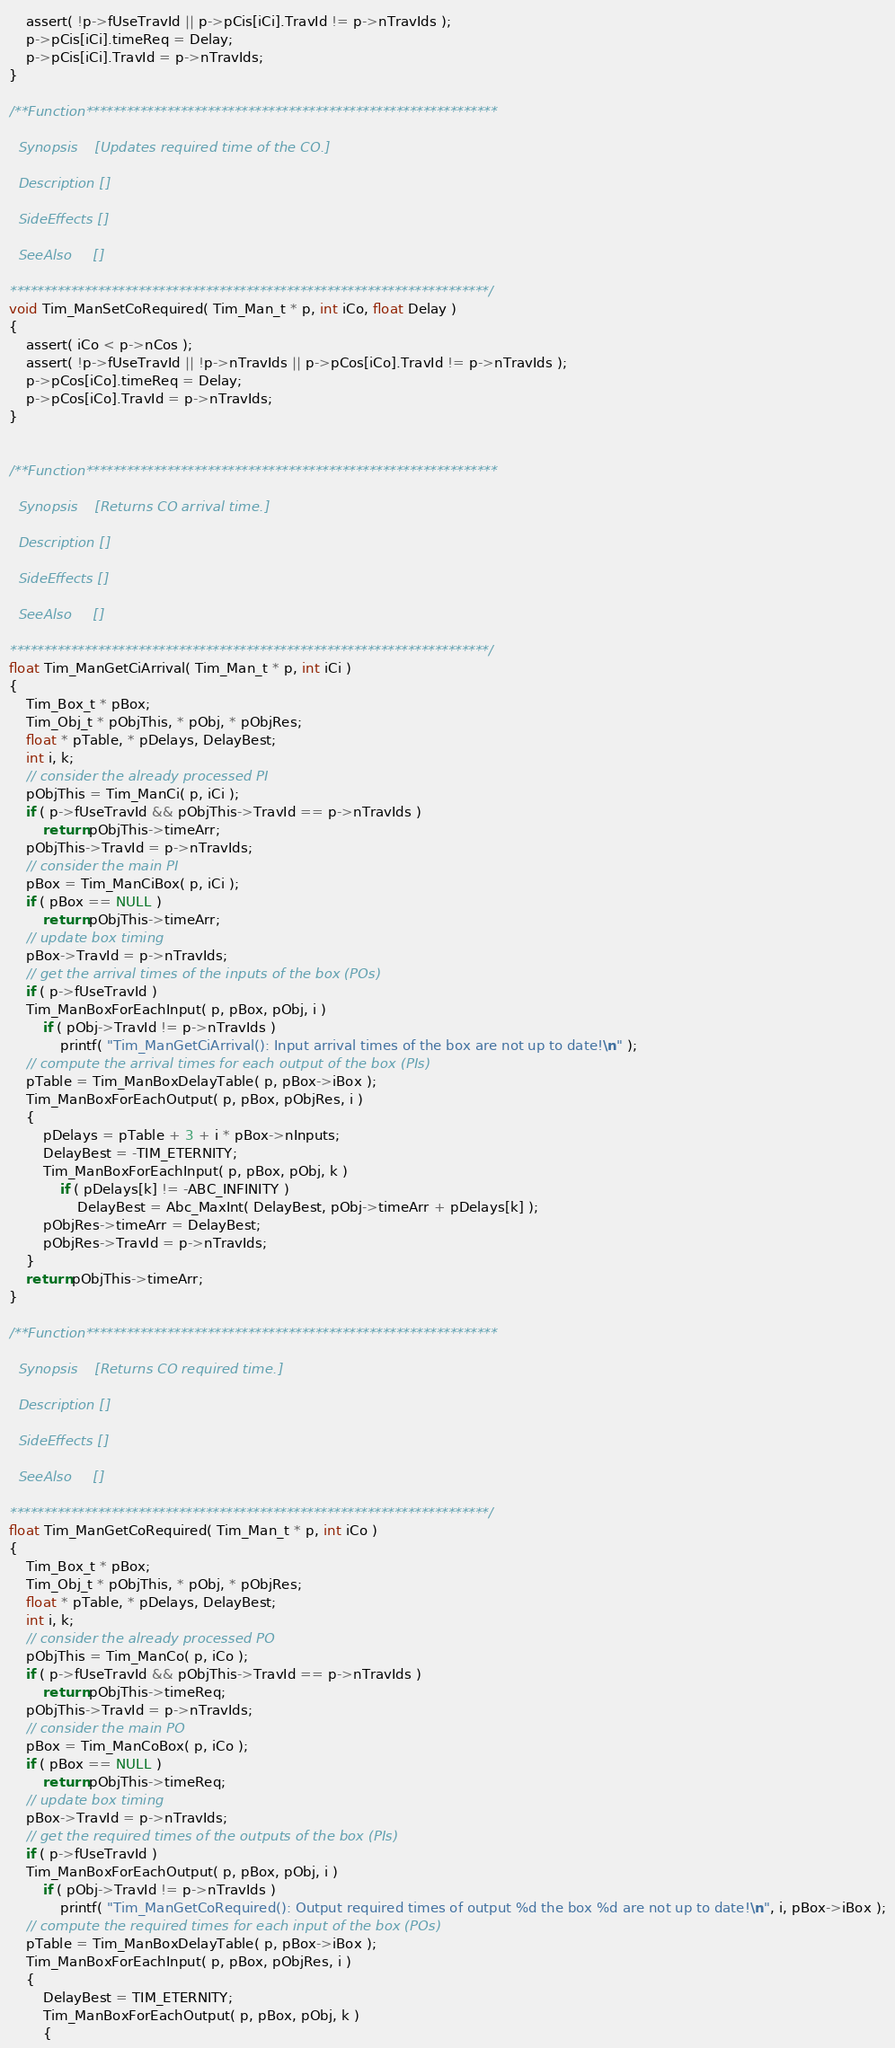Convert code to text. <code><loc_0><loc_0><loc_500><loc_500><_C_>    assert( !p->fUseTravId || p->pCis[iCi].TravId != p->nTravIds );
    p->pCis[iCi].timeReq = Delay;
    p->pCis[iCi].TravId = p->nTravIds;
}

/**Function*************************************************************

  Synopsis    [Updates required time of the CO.]

  Description []
               
  SideEffects []

  SeeAlso     []

***********************************************************************/
void Tim_ManSetCoRequired( Tim_Man_t * p, int iCo, float Delay )
{
    assert( iCo < p->nCos );
    assert( !p->fUseTravId || !p->nTravIds || p->pCos[iCo].TravId != p->nTravIds );
    p->pCos[iCo].timeReq = Delay;
    p->pCos[iCo].TravId = p->nTravIds;
}


/**Function*************************************************************

  Synopsis    [Returns CO arrival time.]

  Description []
               
  SideEffects []

  SeeAlso     []

***********************************************************************/
float Tim_ManGetCiArrival( Tim_Man_t * p, int iCi )
{
    Tim_Box_t * pBox;
    Tim_Obj_t * pObjThis, * pObj, * pObjRes;
    float * pTable, * pDelays, DelayBest;
    int i, k;
    // consider the already processed PI
    pObjThis = Tim_ManCi( p, iCi );
    if ( p->fUseTravId && pObjThis->TravId == p->nTravIds )
        return pObjThis->timeArr;
    pObjThis->TravId = p->nTravIds;
    // consider the main PI
    pBox = Tim_ManCiBox( p, iCi );
    if ( pBox == NULL )
        return pObjThis->timeArr;
    // update box timing
    pBox->TravId = p->nTravIds;
    // get the arrival times of the inputs of the box (POs)
    if ( p->fUseTravId )
    Tim_ManBoxForEachInput( p, pBox, pObj, i )
        if ( pObj->TravId != p->nTravIds )
            printf( "Tim_ManGetCiArrival(): Input arrival times of the box are not up to date!\n" );
    // compute the arrival times for each output of the box (PIs)
    pTable = Tim_ManBoxDelayTable( p, pBox->iBox );
    Tim_ManBoxForEachOutput( p, pBox, pObjRes, i )
    {
        pDelays = pTable + 3 + i * pBox->nInputs;
        DelayBest = -TIM_ETERNITY;
        Tim_ManBoxForEachInput( p, pBox, pObj, k )
			if ( pDelays[k] != -ABC_INFINITY )
				DelayBest = Abc_MaxInt( DelayBest, pObj->timeArr + pDelays[k] );
        pObjRes->timeArr = DelayBest;
        pObjRes->TravId = p->nTravIds;
    }
    return pObjThis->timeArr;
}

/**Function*************************************************************

  Synopsis    [Returns CO required time.]

  Description []
               
  SideEffects []

  SeeAlso     []

***********************************************************************/
float Tim_ManGetCoRequired( Tim_Man_t * p, int iCo )
{
    Tim_Box_t * pBox;
    Tim_Obj_t * pObjThis, * pObj, * pObjRes;
    float * pTable, * pDelays, DelayBest;
    int i, k;
    // consider the already processed PO
    pObjThis = Tim_ManCo( p, iCo );
    if ( p->fUseTravId && pObjThis->TravId == p->nTravIds )
        return pObjThis->timeReq;
    pObjThis->TravId = p->nTravIds;
    // consider the main PO
    pBox = Tim_ManCoBox( p, iCo );
    if ( pBox == NULL )
        return pObjThis->timeReq;
    // update box timing
    pBox->TravId = p->nTravIds;
    // get the required times of the outputs of the box (PIs)
    if ( p->fUseTravId )
    Tim_ManBoxForEachOutput( p, pBox, pObj, i )
        if ( pObj->TravId != p->nTravIds )
            printf( "Tim_ManGetCoRequired(): Output required times of output %d the box %d are not up to date!\n", i, pBox->iBox );
    // compute the required times for each input of the box (POs)
    pTable = Tim_ManBoxDelayTable( p, pBox->iBox );
    Tim_ManBoxForEachInput( p, pBox, pObjRes, i )
    {
        DelayBest = TIM_ETERNITY;
        Tim_ManBoxForEachOutput( p, pBox, pObj, k )
        {</code> 